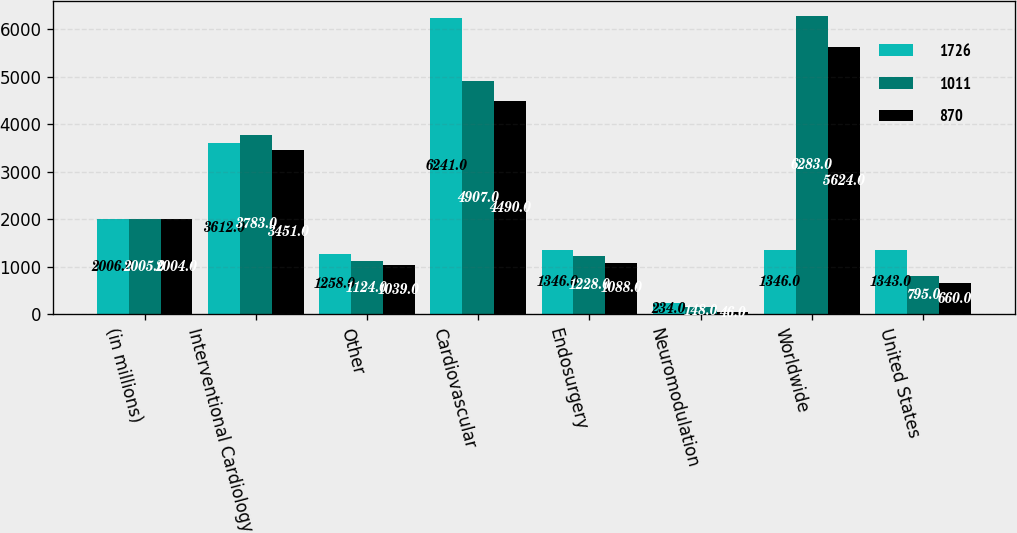<chart> <loc_0><loc_0><loc_500><loc_500><stacked_bar_chart><ecel><fcel>(in millions)<fcel>Interventional Cardiology<fcel>Other<fcel>Cardiovascular<fcel>Endosurgery<fcel>Neuromodulation<fcel>Worldwide<fcel>United States<nl><fcel>1726<fcel>2006<fcel>3612<fcel>1258<fcel>6241<fcel>1346<fcel>234<fcel>1346<fcel>1343<nl><fcel>1011<fcel>2005<fcel>3783<fcel>1124<fcel>4907<fcel>1228<fcel>148<fcel>6283<fcel>795<nl><fcel>870<fcel>2004<fcel>3451<fcel>1039<fcel>4490<fcel>1088<fcel>46<fcel>5624<fcel>660<nl></chart> 